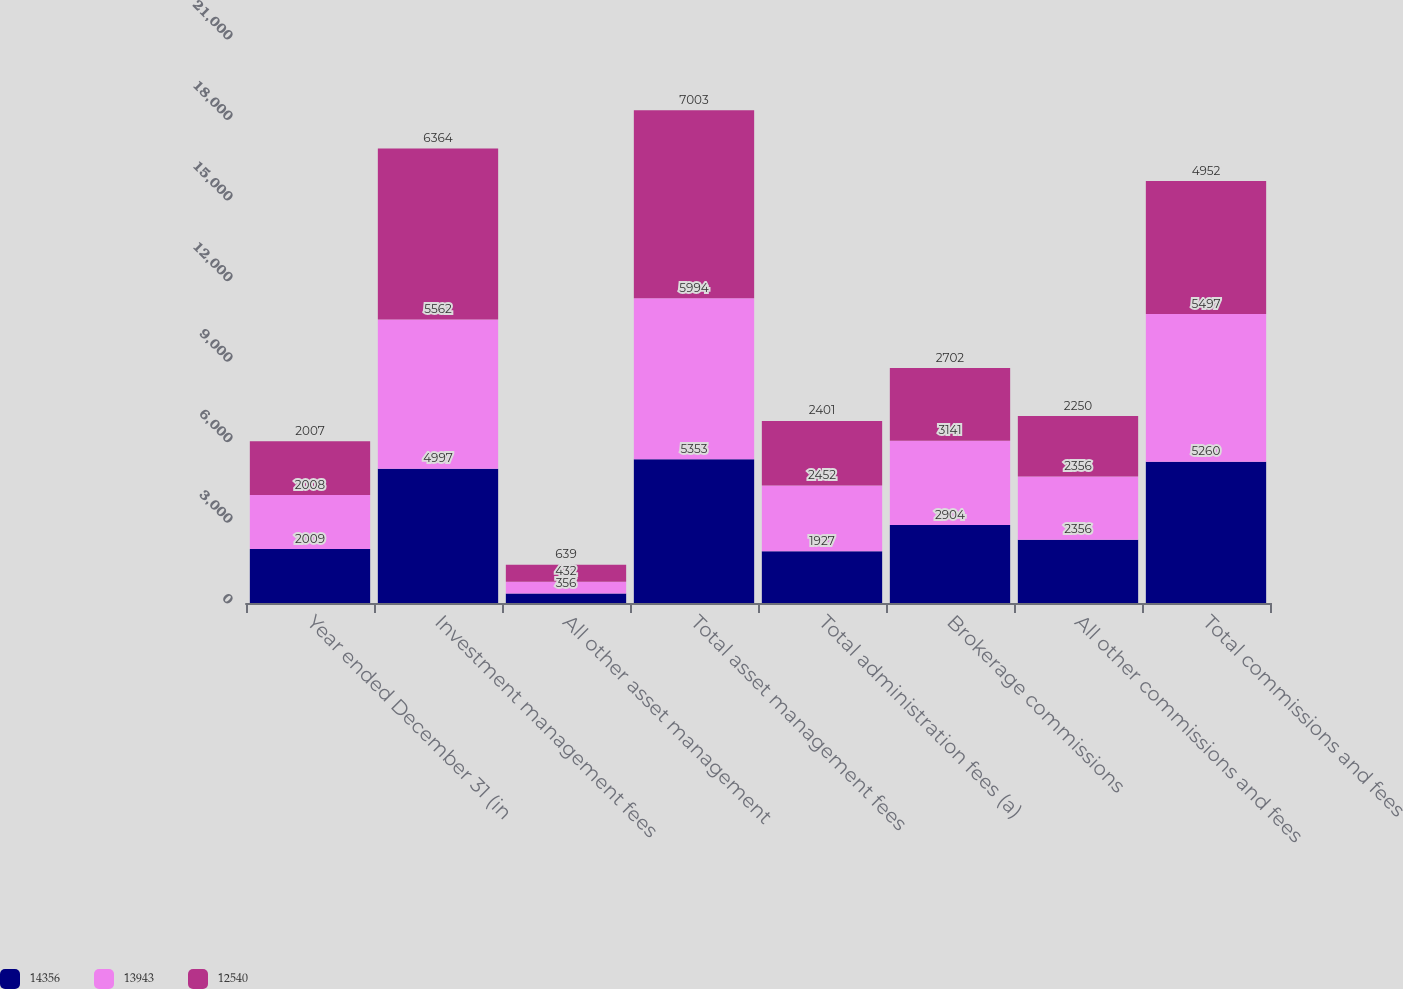<chart> <loc_0><loc_0><loc_500><loc_500><stacked_bar_chart><ecel><fcel>Year ended December 31 (in<fcel>Investment management fees<fcel>All other asset management<fcel>Total asset management fees<fcel>Total administration fees (a)<fcel>Brokerage commissions<fcel>All other commissions and fees<fcel>Total commissions and fees<nl><fcel>14356<fcel>2009<fcel>4997<fcel>356<fcel>5353<fcel>1927<fcel>2904<fcel>2356<fcel>5260<nl><fcel>13943<fcel>2008<fcel>5562<fcel>432<fcel>5994<fcel>2452<fcel>3141<fcel>2356<fcel>5497<nl><fcel>12540<fcel>2007<fcel>6364<fcel>639<fcel>7003<fcel>2401<fcel>2702<fcel>2250<fcel>4952<nl></chart> 